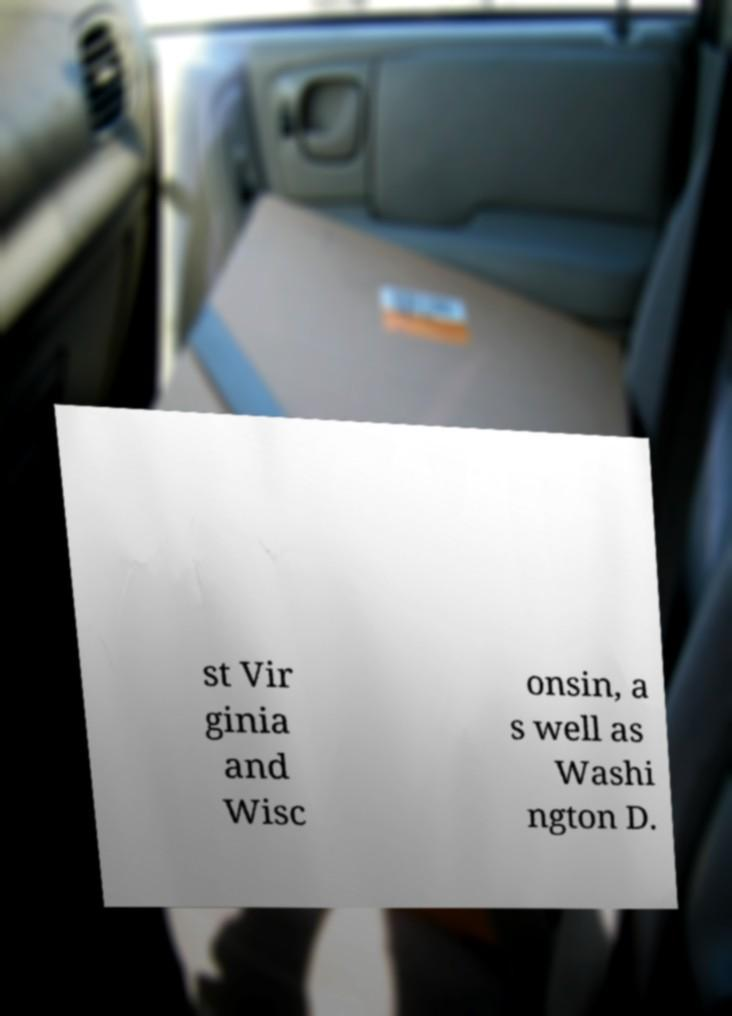Please identify and transcribe the text found in this image. st Vir ginia and Wisc onsin, a s well as Washi ngton D. 